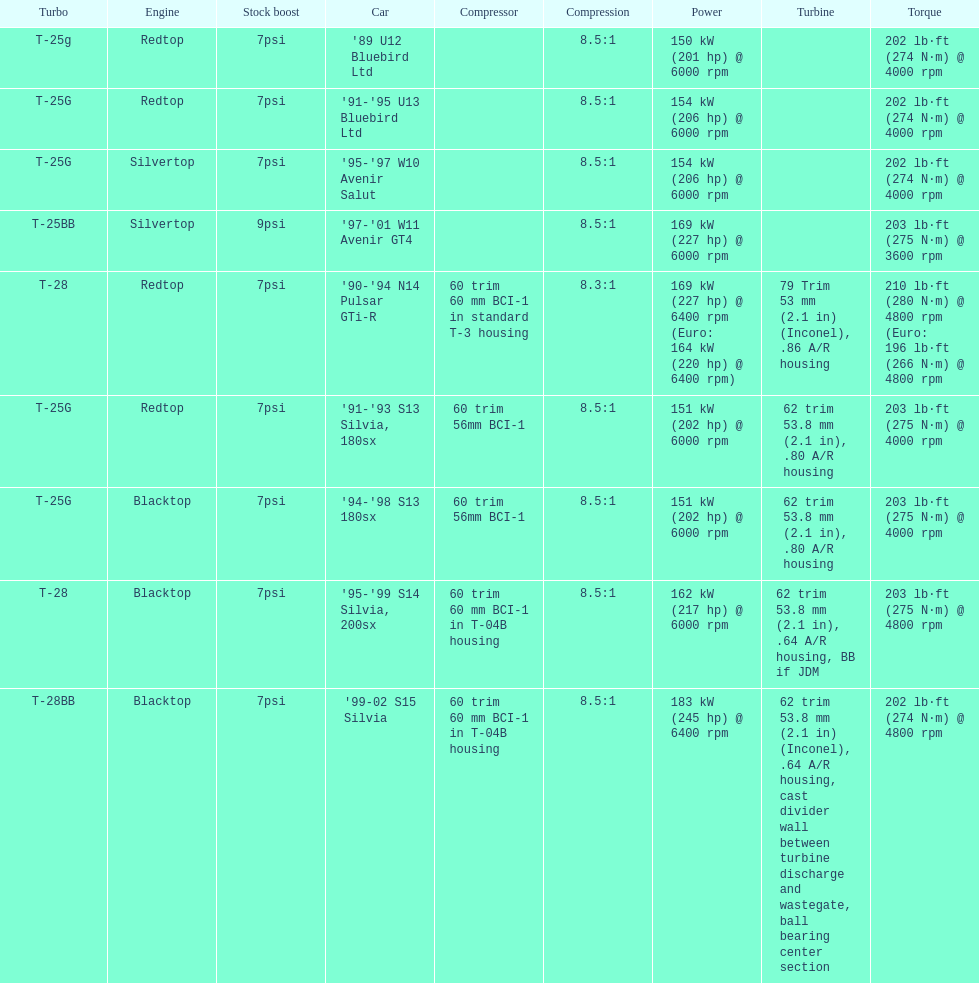What are the psi's? 7psi, 7psi, 7psi, 9psi, 7psi, 7psi, 7psi, 7psi, 7psi. What are the number(s) greater than 7? 9psi. Which car has that number? '97-'01 W11 Avenir GT4. 